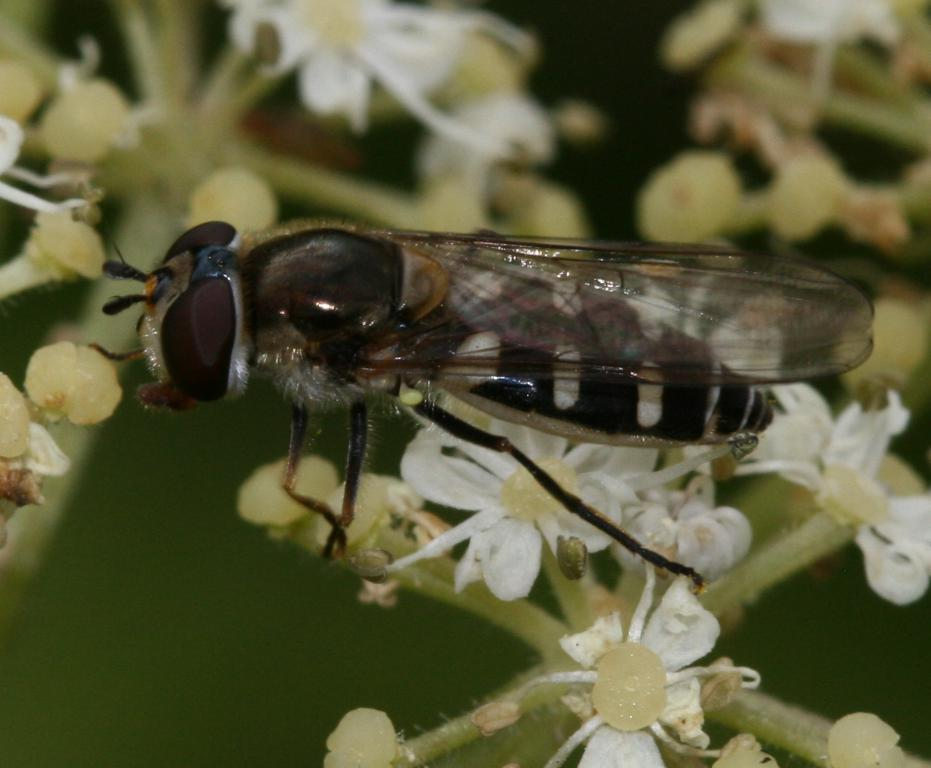What type of flowers can be seen in the image? There are white-colored flowers in the image. What color are the other objects or elements in the image? There are green-colored things in the image. What insect is present in the image? There is a housefly in the front of the image. How would you describe the background of the image? The background of the image is blurry. What grade is the student sitting on the chair in the image? There is no student or chair present in the image; it features white-colored flowers, green-colored things, a housefly. 